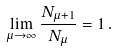Convert formula to latex. <formula><loc_0><loc_0><loc_500><loc_500>\lim _ { \mu \to \infty } \frac { N _ { \mu + 1 } } { N _ { \mu } } = 1 \, .</formula> 